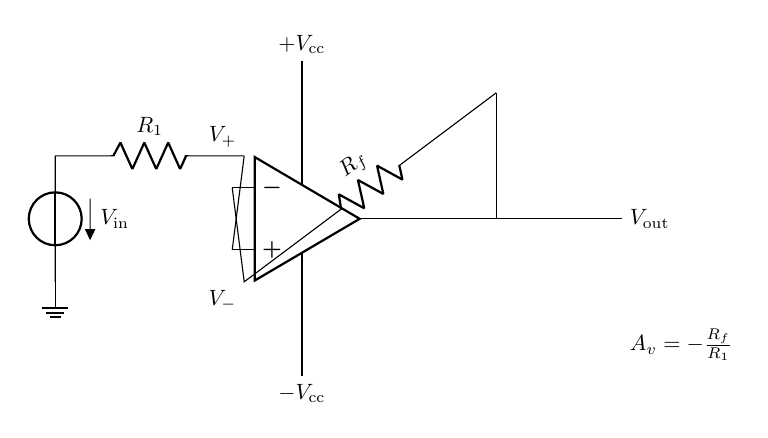What is the power supply voltage used in the circuit? The power supply voltage for the op-amp is indicated as +V_cc and -V_cc, showing the positive and negative supply voltages needed for the operation of the amplifier.
Answer: +V_cc, -V_cc What is the purpose of resistor R_1 in this circuit? Resistor R_1 is the input resistor that sets the input sensitivity of the circuit, defining how much of the input voltage is applied to the op-amp.
Answer: Input sensitivity What is the output voltage expression given in the circuit? The output voltage expression is given as A_v = -R_f/R_1, representing the voltage gain of the amplifier, showing how the input voltage is amplified based on the resistors.
Answer: A_v = -R_f/R_1 What type of feedback is used in this amplifier circuit? The feedback used is negative feedback, as the output is fed back to the inverting input of the op-amp, which helps stabilize the gain and reduce distortion.
Answer: Negative feedback What happens to the gain if resistor R_f is increased? If resistor R_f is increased, the absolute value of the voltage gain A_v becomes larger, indicating greater amplification of the input signal because the gain equation shows direct proportionality to R_f.
Answer: Gain increases What identifies this circuit as an operational amplifier configuration? The use of an operational amplifier component, along with its specific connections for both the input and feedback resistors, distinguishes this configuration for precise signal processing and amplification.
Answer: Operational amplifier What is the significance of the labels V_+ and V_-? V_+ and V_- indicate the positive and negative input terminals of the op-amp, where V_+ is the non-inverting input and V_- is the inverting input, essential for the operation of the amplifier.
Answer: Input terminals 